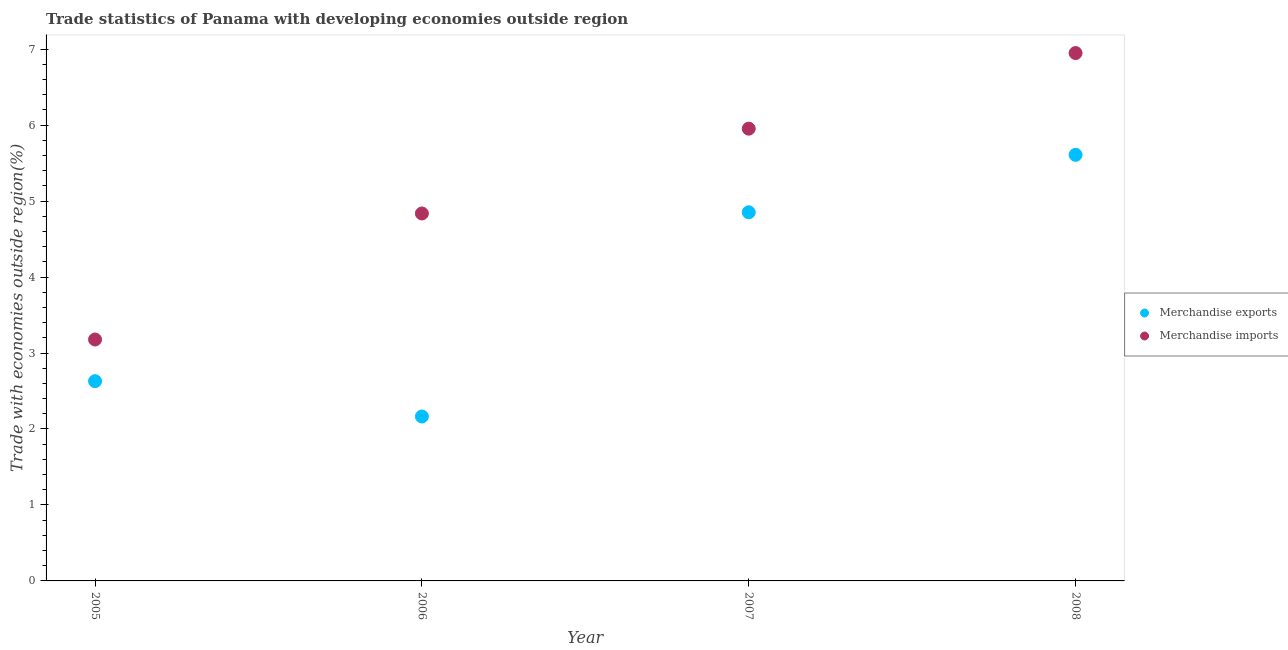How many different coloured dotlines are there?
Ensure brevity in your answer.  2. Is the number of dotlines equal to the number of legend labels?
Offer a terse response. Yes. What is the merchandise exports in 2008?
Keep it short and to the point. 5.61. Across all years, what is the maximum merchandise imports?
Your answer should be compact. 6.95. Across all years, what is the minimum merchandise imports?
Provide a succinct answer. 3.18. In which year was the merchandise exports minimum?
Provide a succinct answer. 2006. What is the total merchandise exports in the graph?
Make the answer very short. 15.25. What is the difference between the merchandise imports in 2007 and that in 2008?
Your response must be concise. -1. What is the difference between the merchandise exports in 2006 and the merchandise imports in 2005?
Ensure brevity in your answer.  -1.01. What is the average merchandise imports per year?
Make the answer very short. 5.23. In the year 2006, what is the difference between the merchandise exports and merchandise imports?
Give a very brief answer. -2.67. In how many years, is the merchandise imports greater than 3 %?
Your response must be concise. 4. What is the ratio of the merchandise exports in 2006 to that in 2007?
Offer a terse response. 0.45. What is the difference between the highest and the second highest merchandise exports?
Ensure brevity in your answer.  0.76. What is the difference between the highest and the lowest merchandise exports?
Make the answer very short. 3.44. Is the merchandise imports strictly less than the merchandise exports over the years?
Offer a very short reply. No. Does the graph contain any zero values?
Your answer should be compact. No. What is the title of the graph?
Provide a succinct answer. Trade statistics of Panama with developing economies outside region. Does "Transport services" appear as one of the legend labels in the graph?
Keep it short and to the point. No. What is the label or title of the X-axis?
Make the answer very short. Year. What is the label or title of the Y-axis?
Make the answer very short. Trade with economies outside region(%). What is the Trade with economies outside region(%) of Merchandise exports in 2005?
Provide a succinct answer. 2.63. What is the Trade with economies outside region(%) of Merchandise imports in 2005?
Offer a very short reply. 3.18. What is the Trade with economies outside region(%) in Merchandise exports in 2006?
Your answer should be very brief. 2.16. What is the Trade with economies outside region(%) in Merchandise imports in 2006?
Give a very brief answer. 4.84. What is the Trade with economies outside region(%) of Merchandise exports in 2007?
Ensure brevity in your answer.  4.85. What is the Trade with economies outside region(%) of Merchandise imports in 2007?
Your response must be concise. 5.95. What is the Trade with economies outside region(%) in Merchandise exports in 2008?
Make the answer very short. 5.61. What is the Trade with economies outside region(%) in Merchandise imports in 2008?
Make the answer very short. 6.95. Across all years, what is the maximum Trade with economies outside region(%) in Merchandise exports?
Offer a very short reply. 5.61. Across all years, what is the maximum Trade with economies outside region(%) in Merchandise imports?
Your answer should be compact. 6.95. Across all years, what is the minimum Trade with economies outside region(%) in Merchandise exports?
Offer a terse response. 2.16. Across all years, what is the minimum Trade with economies outside region(%) of Merchandise imports?
Ensure brevity in your answer.  3.18. What is the total Trade with economies outside region(%) in Merchandise exports in the graph?
Your answer should be compact. 15.25. What is the total Trade with economies outside region(%) of Merchandise imports in the graph?
Provide a short and direct response. 20.92. What is the difference between the Trade with economies outside region(%) in Merchandise exports in 2005 and that in 2006?
Give a very brief answer. 0.46. What is the difference between the Trade with economies outside region(%) of Merchandise imports in 2005 and that in 2006?
Offer a terse response. -1.66. What is the difference between the Trade with economies outside region(%) in Merchandise exports in 2005 and that in 2007?
Give a very brief answer. -2.22. What is the difference between the Trade with economies outside region(%) of Merchandise imports in 2005 and that in 2007?
Keep it short and to the point. -2.78. What is the difference between the Trade with economies outside region(%) in Merchandise exports in 2005 and that in 2008?
Give a very brief answer. -2.98. What is the difference between the Trade with economies outside region(%) of Merchandise imports in 2005 and that in 2008?
Offer a terse response. -3.77. What is the difference between the Trade with economies outside region(%) of Merchandise exports in 2006 and that in 2007?
Make the answer very short. -2.69. What is the difference between the Trade with economies outside region(%) of Merchandise imports in 2006 and that in 2007?
Provide a short and direct response. -1.12. What is the difference between the Trade with economies outside region(%) of Merchandise exports in 2006 and that in 2008?
Offer a terse response. -3.44. What is the difference between the Trade with economies outside region(%) of Merchandise imports in 2006 and that in 2008?
Your answer should be compact. -2.11. What is the difference between the Trade with economies outside region(%) in Merchandise exports in 2007 and that in 2008?
Your answer should be very brief. -0.76. What is the difference between the Trade with economies outside region(%) of Merchandise imports in 2007 and that in 2008?
Your answer should be compact. -1. What is the difference between the Trade with economies outside region(%) of Merchandise exports in 2005 and the Trade with economies outside region(%) of Merchandise imports in 2006?
Provide a short and direct response. -2.21. What is the difference between the Trade with economies outside region(%) of Merchandise exports in 2005 and the Trade with economies outside region(%) of Merchandise imports in 2007?
Keep it short and to the point. -3.32. What is the difference between the Trade with economies outside region(%) of Merchandise exports in 2005 and the Trade with economies outside region(%) of Merchandise imports in 2008?
Ensure brevity in your answer.  -4.32. What is the difference between the Trade with economies outside region(%) of Merchandise exports in 2006 and the Trade with economies outside region(%) of Merchandise imports in 2007?
Your answer should be compact. -3.79. What is the difference between the Trade with economies outside region(%) of Merchandise exports in 2006 and the Trade with economies outside region(%) of Merchandise imports in 2008?
Offer a very short reply. -4.78. What is the difference between the Trade with economies outside region(%) of Merchandise exports in 2007 and the Trade with economies outside region(%) of Merchandise imports in 2008?
Give a very brief answer. -2.1. What is the average Trade with economies outside region(%) of Merchandise exports per year?
Provide a short and direct response. 3.81. What is the average Trade with economies outside region(%) of Merchandise imports per year?
Make the answer very short. 5.23. In the year 2005, what is the difference between the Trade with economies outside region(%) in Merchandise exports and Trade with economies outside region(%) in Merchandise imports?
Give a very brief answer. -0.55. In the year 2006, what is the difference between the Trade with economies outside region(%) in Merchandise exports and Trade with economies outside region(%) in Merchandise imports?
Your answer should be compact. -2.67. In the year 2007, what is the difference between the Trade with economies outside region(%) in Merchandise exports and Trade with economies outside region(%) in Merchandise imports?
Keep it short and to the point. -1.1. In the year 2008, what is the difference between the Trade with economies outside region(%) of Merchandise exports and Trade with economies outside region(%) of Merchandise imports?
Your answer should be compact. -1.34. What is the ratio of the Trade with economies outside region(%) in Merchandise exports in 2005 to that in 2006?
Offer a terse response. 1.21. What is the ratio of the Trade with economies outside region(%) in Merchandise imports in 2005 to that in 2006?
Give a very brief answer. 0.66. What is the ratio of the Trade with economies outside region(%) in Merchandise exports in 2005 to that in 2007?
Your response must be concise. 0.54. What is the ratio of the Trade with economies outside region(%) of Merchandise imports in 2005 to that in 2007?
Your answer should be very brief. 0.53. What is the ratio of the Trade with economies outside region(%) of Merchandise exports in 2005 to that in 2008?
Your answer should be very brief. 0.47. What is the ratio of the Trade with economies outside region(%) of Merchandise imports in 2005 to that in 2008?
Keep it short and to the point. 0.46. What is the ratio of the Trade with economies outside region(%) in Merchandise exports in 2006 to that in 2007?
Keep it short and to the point. 0.45. What is the ratio of the Trade with economies outside region(%) of Merchandise imports in 2006 to that in 2007?
Provide a succinct answer. 0.81. What is the ratio of the Trade with economies outside region(%) in Merchandise exports in 2006 to that in 2008?
Ensure brevity in your answer.  0.39. What is the ratio of the Trade with economies outside region(%) in Merchandise imports in 2006 to that in 2008?
Ensure brevity in your answer.  0.7. What is the ratio of the Trade with economies outside region(%) of Merchandise exports in 2007 to that in 2008?
Your answer should be compact. 0.87. What is the ratio of the Trade with economies outside region(%) of Merchandise imports in 2007 to that in 2008?
Your response must be concise. 0.86. What is the difference between the highest and the second highest Trade with economies outside region(%) in Merchandise exports?
Give a very brief answer. 0.76. What is the difference between the highest and the lowest Trade with economies outside region(%) in Merchandise exports?
Provide a short and direct response. 3.44. What is the difference between the highest and the lowest Trade with economies outside region(%) of Merchandise imports?
Offer a very short reply. 3.77. 